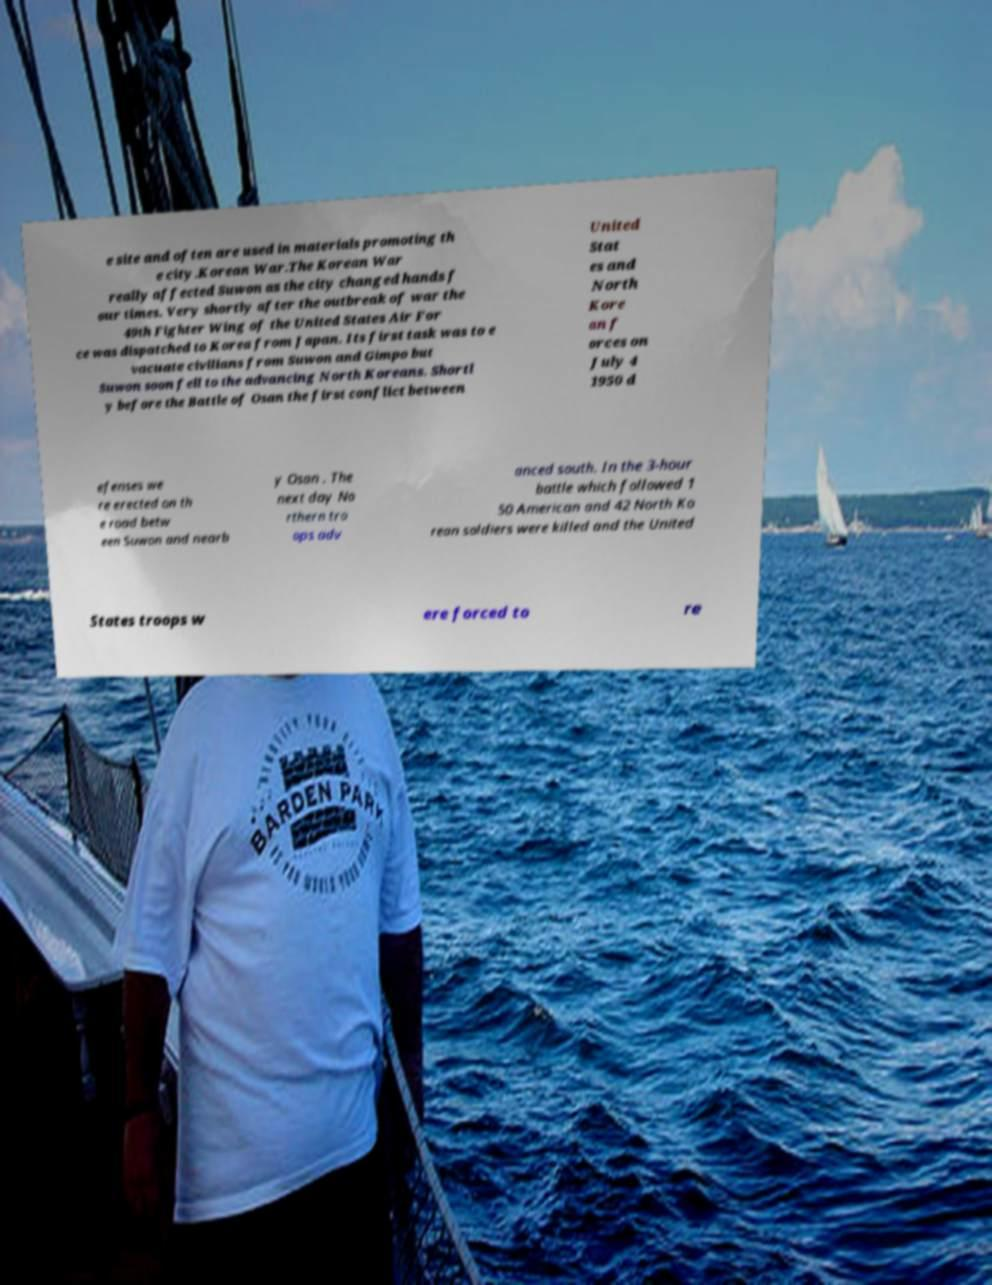Can you accurately transcribe the text from the provided image for me? e site and often are used in materials promoting th e city.Korean War.The Korean War really affected Suwon as the city changed hands f our times. Very shortly after the outbreak of war the 49th Fighter Wing of the United States Air For ce was dispatched to Korea from Japan. Its first task was to e vacuate civilians from Suwon and Gimpo but Suwon soon fell to the advancing North Koreans. Shortl y before the Battle of Osan the first conflict between United Stat es and North Kore an f orces on July 4 1950 d efenses we re erected on th e road betw een Suwon and nearb y Osan . The next day No rthern tro ops adv anced south. In the 3-hour battle which followed 1 50 American and 42 North Ko rean soldiers were killed and the United States troops w ere forced to re 